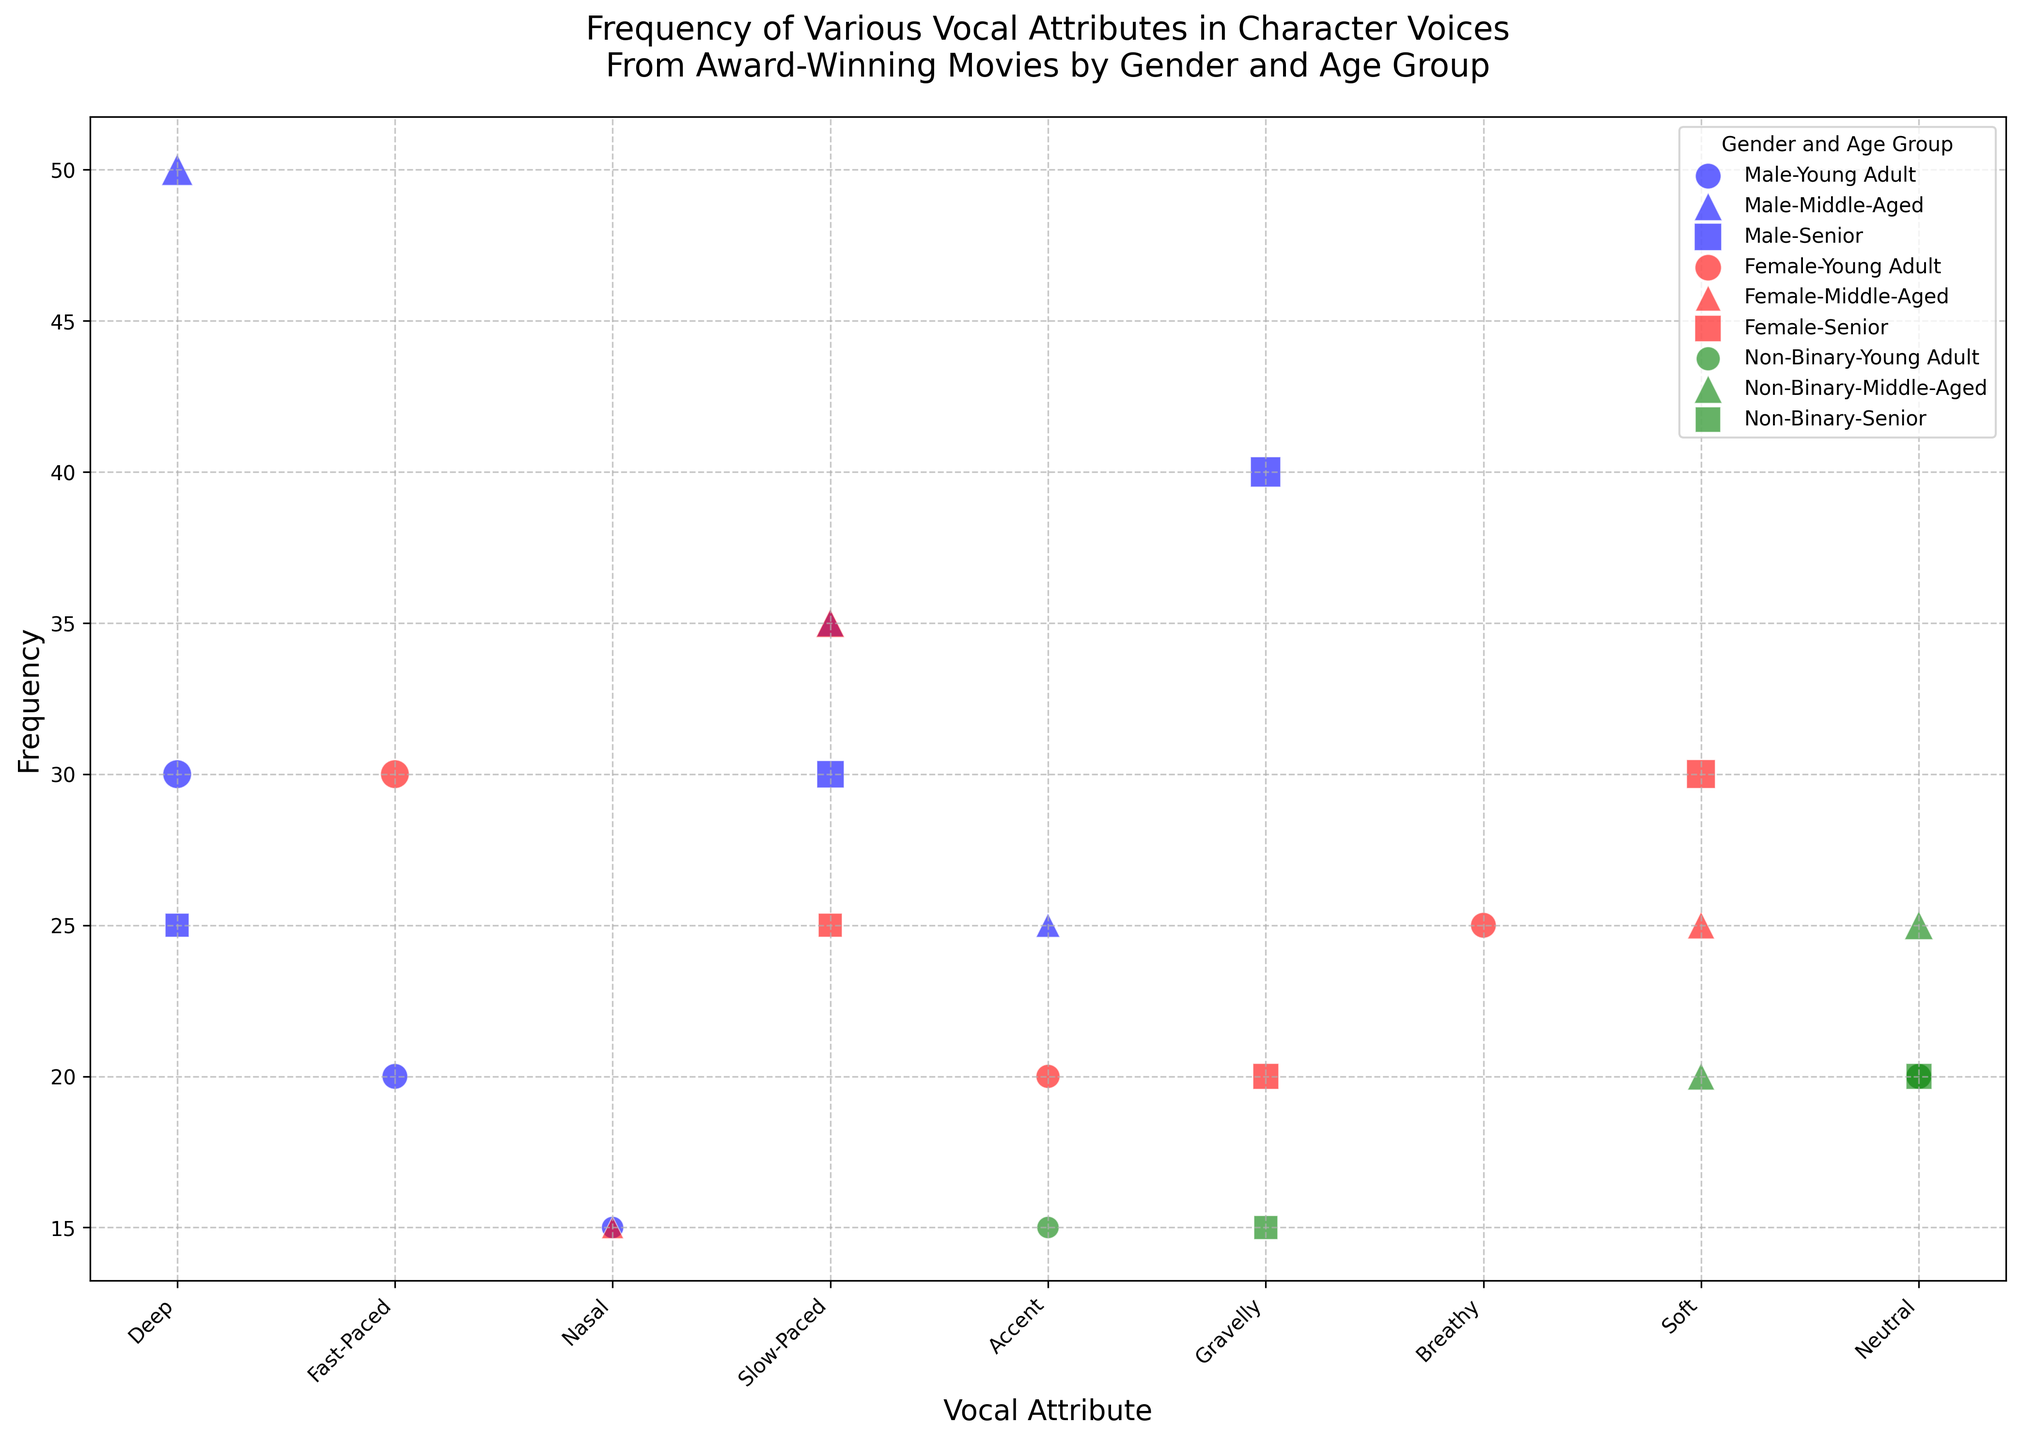Which gender and age group has the highest frequency for the 'Deep' vocal attribute? By looking at the plot, find the largest bubble for the 'Deep' vocal attribute. The largest bubble for 'Deep' is for Male Middle-Aged with a frequency of 50. Thus, Male Middle-Aged has the highest frequency for the 'Deep' vocal attribute.
Answer: Male Middle-Aged Comparing 'Fast-Paced' attribute, which gender and age group is represented more frequently, Male Young Adult or Female Young Adult? Identify the frequencies for the 'Fast-Paced' attribute for both Male Young Adult and Female Young Adult in the plot. Male Young Adult has a frequency of 20, whereas Female Young Adult has a frequency of 30. Therefore, Female Young Adult is represented more frequently.
Answer: Female Young Adult Which gender and age group combination has the greatest variety of vocal attributes? Count the different vocal attributes (bubbles) for each gender and age group combination. The combinations with the most distinct attributes are considered to have the greatest variety. Based on visual inspection, Male Middle-Aged and Female Senior both cover a wide range of attributes.
Answer: Male Middle-Aged and Female Senior For the 'Gravelly' attribute, which age group shows a higher frequency among Males and Females? Identify and compare the frequencies of the 'Gravelly' attribute for each age group among Males and Females. For Males Senior, the frequency is 40, and for Females Senior, it is 20. Thus, Males in the Senior age group show a higher frequency.
Answer: Males Senior What is the sum of the frequencies for the 'Slow-Paced' attribute across all gender and age groups? Sum the frequencies of the 'Slow-Paced' attribute from each gender and age group. The frequencies are: Male Middle-Aged (35), Male Senior (30), Female Middle-Aged (35), Female Senior (25). Sum = 35 + 30 + 35 + 25 = 125.
Answer: 125 How many distinct vocal attributes are there in the plot? Count the unique vocal attributes mentioned in the plot. The vocal attributes are Deep, Fast-Paced, Nasal, Accent, Slow-Paced, Breathy, Soft, Gravelly, and Neutral. There are 9 distinct vocal attributes.
Answer: 9 Does the Non-Binary gender category show a higher or lower frequency for the 'Accent' attribute compared to the Female Young Adult group? Check the frequencies of the 'Accent' attribute for Non-Binary and Female Young Adult groups. Non-Binary has a frequency of 15, and Female Young Adult has a frequency of 20. Non-Binary shows a lower frequency.
Answer: Lower What is the shape used to represent the data points for the 'Senior' age group? Identify the marker shape used for the 'Senior' age group in the plot. The 'Senior' age group uses squares (s) as the marker.
Answer: Squares 